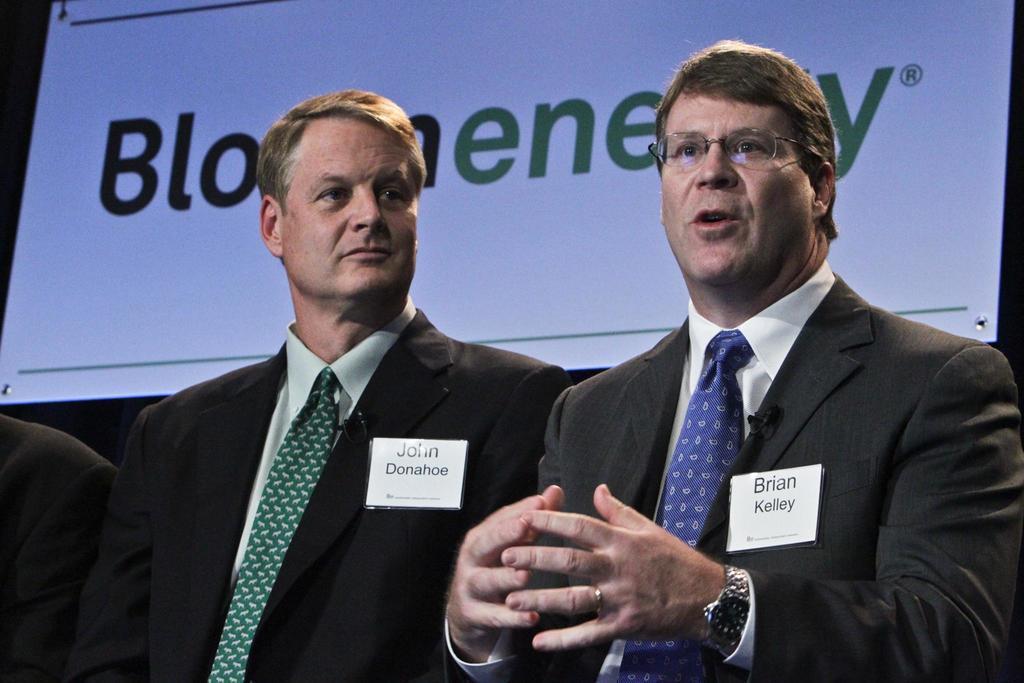Please provide a concise description of this image. In this image, we can see two men standing and they are wearing coats and ties. In the background, we can see a white poster. 